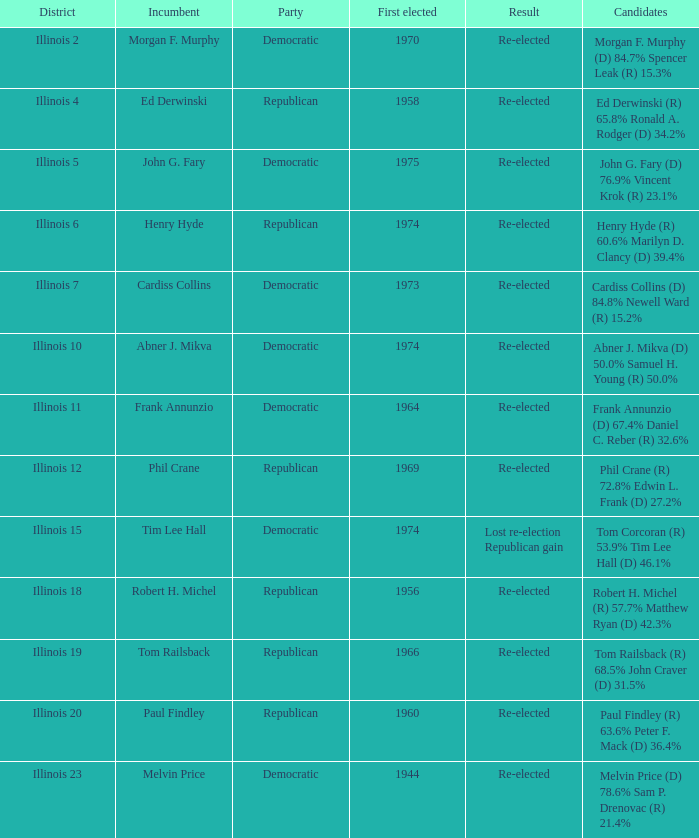Specify the occasion for tim lee hall. Democratic. 